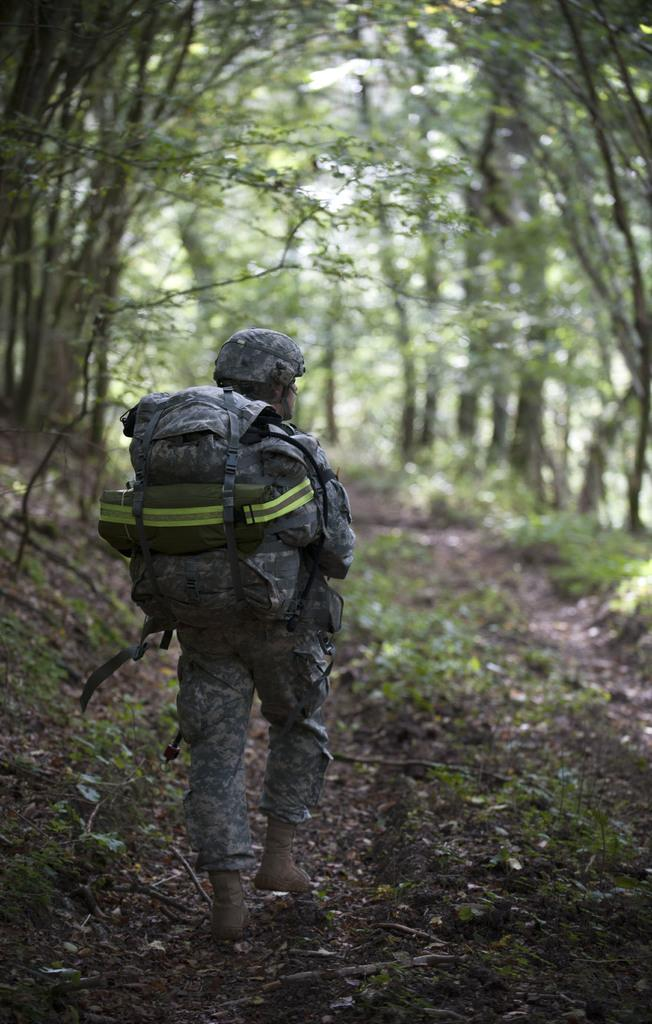What is the main subject of the image? There is a person in the image. What is the person wearing? The person is wearing a uniform. What is the person holding? The person is holding a bag. What is the person doing in the image? The person is walking. What can be seen in the background of the image? There are trees in the background of the image. How many sisters are present in the image? There are no sisters mentioned or visible in the image. What type of lock can be seen on the person's bag? There is no lock visible on the person's bag in the image. 